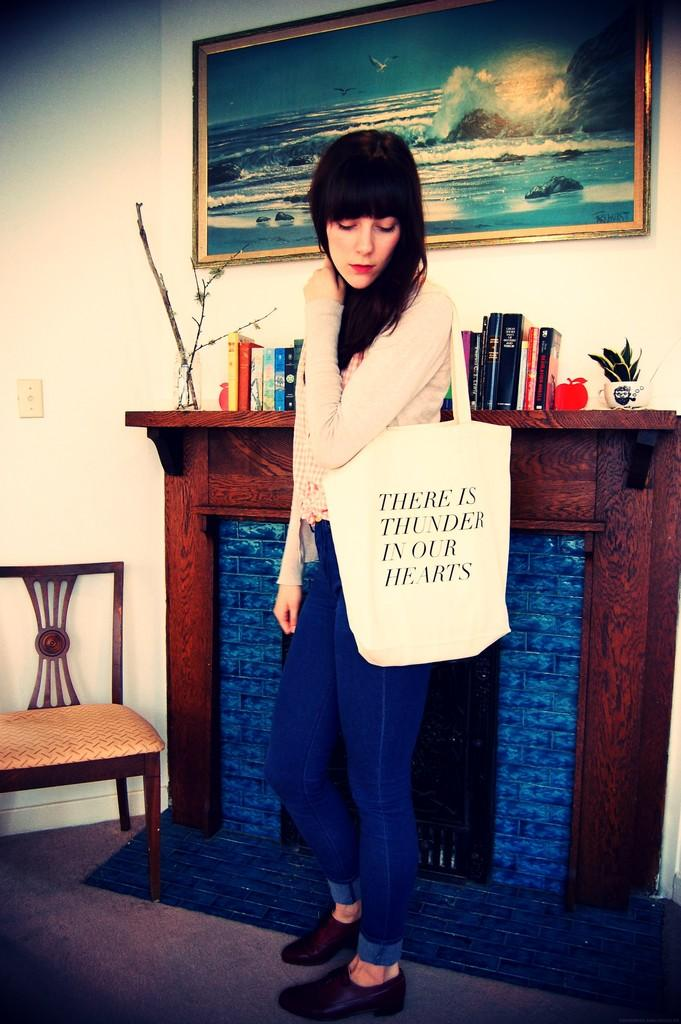What is the main subject of the image? There is a woman standing in the image. What is the woman wearing? The woman is wearing a bag. What is present in the image besides the woman? There is a chair, books, plants, a frame, and a wall in the image. What type of quince can be seen in the image? There is no quince present in the image. How does the woman plan to join the group in the image? The image does not show any group or indication of joining, so it cannot be determined from the image. 